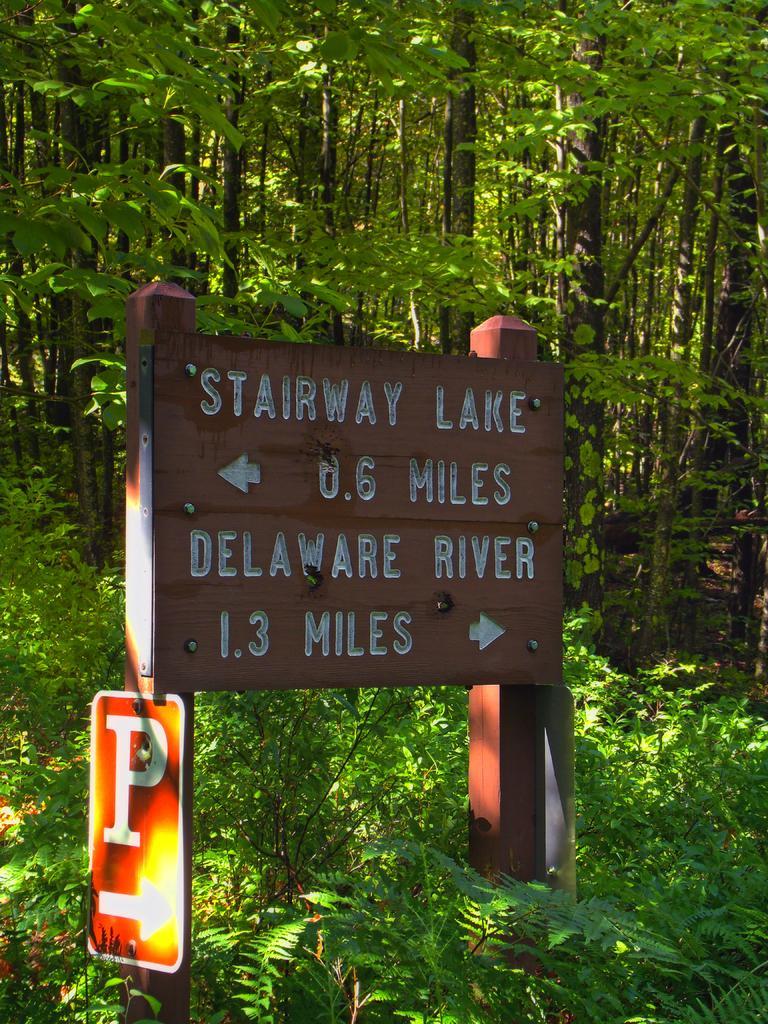Could you give a brief overview of what you see in this image? In this picture we can see sign boards, plants and trees, we can see some text on the board. 